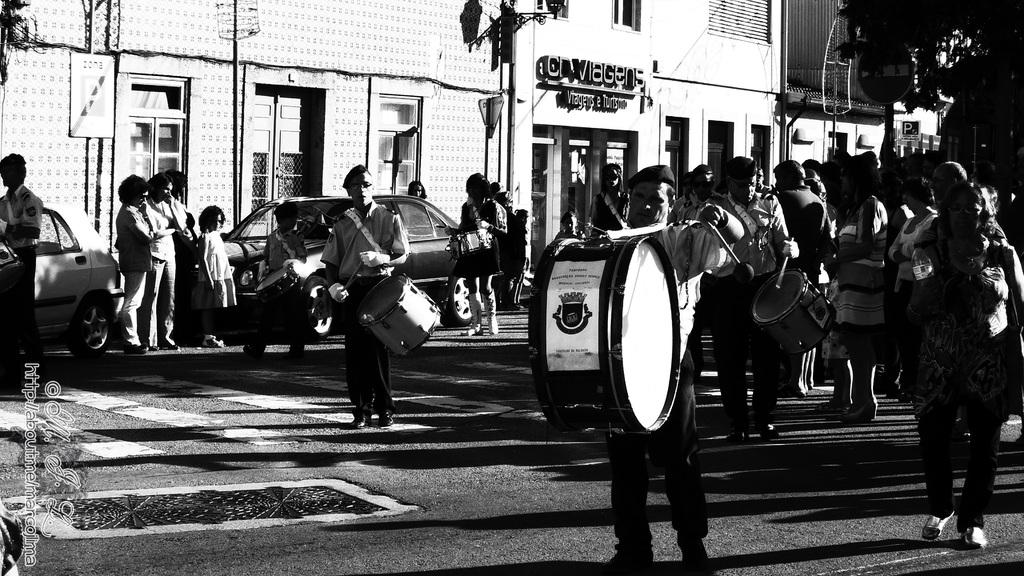How many people are in the image? There is a group of people in the image, but the exact number is not specified. What are some of the people doing in the image? Some people are holding musical instruments in the image. What can be seen on the road in the image? There are vehicles on the road in the image. What is visible in the background of the image? There is a building, a tree, a board, and a pole in the background of the image. What type of whip is being used by the people in the image? There is no whip present in the image. What impulse led the people to gather in the image? The image does not provide information about the reason or impulse for the people to gather. 